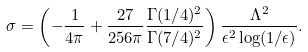Convert formula to latex. <formula><loc_0><loc_0><loc_500><loc_500>\sigma = \left ( - \frac { 1 } { 4 \pi } + \frac { 2 7 } { 2 5 6 \pi } \frac { \Gamma ( 1 / 4 ) ^ { 2 } } { \Gamma ( 7 / 4 ) ^ { 2 } } \right ) \frac { \Lambda ^ { 2 } } { \epsilon ^ { 2 } \log ( 1 / \epsilon ) } .</formula> 